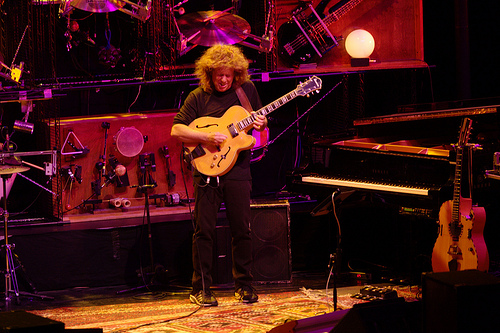<image>
Is there a cymbal above the human? Yes. The cymbal is positioned above the human in the vertical space, higher up in the scene. 